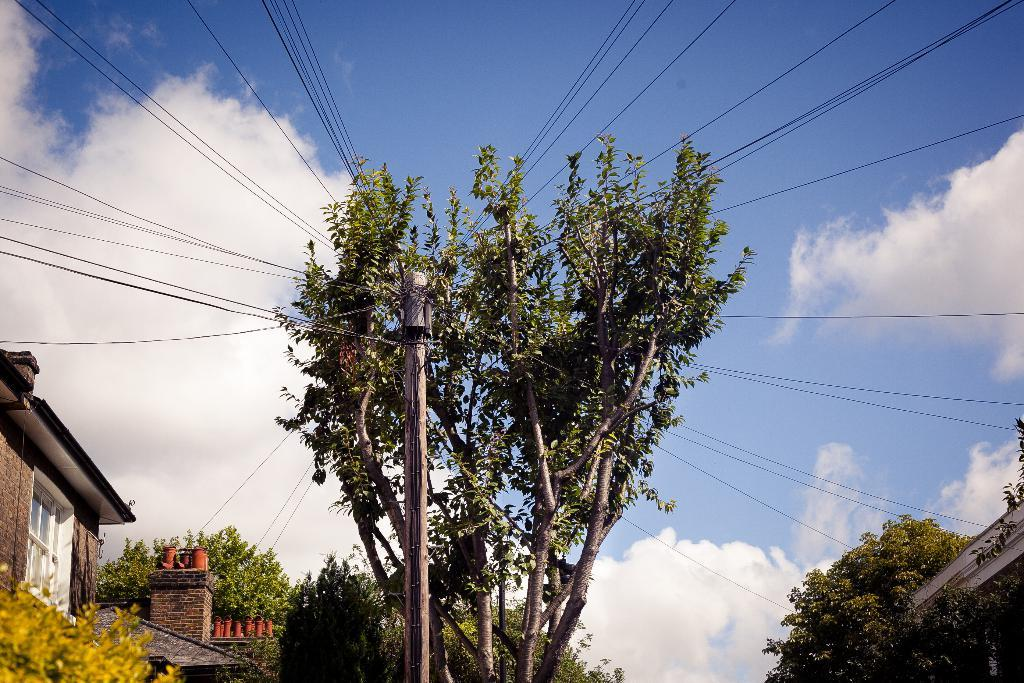What is located in the foreground of the image? There is a pole in the foreground of the image. What is connected to the pole? Wires are attached to the pole. What type of natural elements can be seen around the pole? Trees are present around the pole. What type of structures can be seen around the pole? Houses are visible around the pole. What type of apparel is the pole wearing in the image? The pole is not wearing any apparel, as it is an inanimate object. 